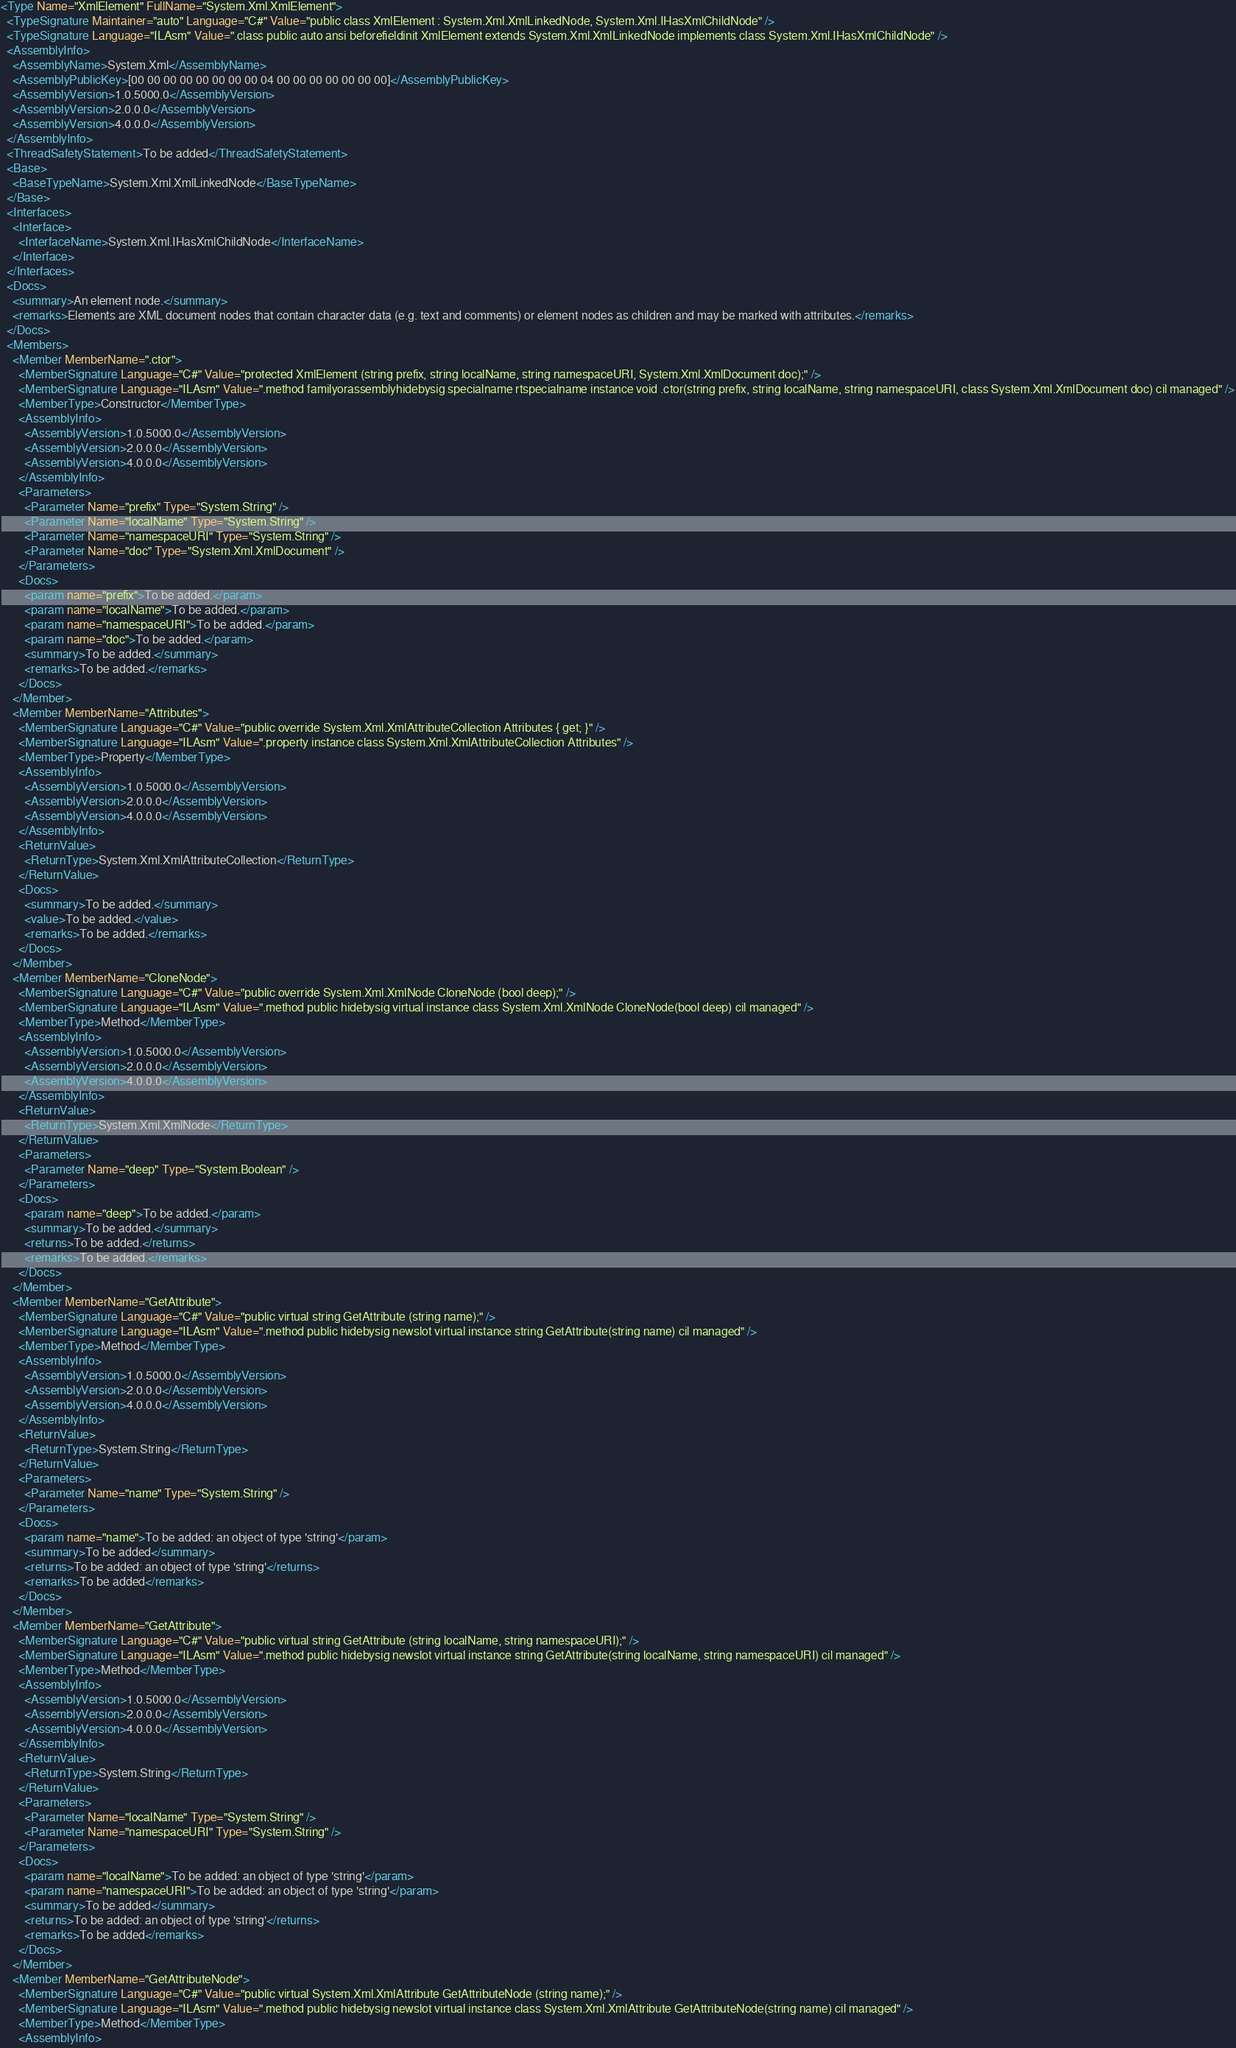<code> <loc_0><loc_0><loc_500><loc_500><_XML_><Type Name="XmlElement" FullName="System.Xml.XmlElement">
  <TypeSignature Maintainer="auto" Language="C#" Value="public class XmlElement : System.Xml.XmlLinkedNode, System.Xml.IHasXmlChildNode" />
  <TypeSignature Language="ILAsm" Value=".class public auto ansi beforefieldinit XmlElement extends System.Xml.XmlLinkedNode implements class System.Xml.IHasXmlChildNode" />
  <AssemblyInfo>
    <AssemblyName>System.Xml</AssemblyName>
    <AssemblyPublicKey>[00 00 00 00 00 00 00 00 04 00 00 00 00 00 00 00]</AssemblyPublicKey>
    <AssemblyVersion>1.0.5000.0</AssemblyVersion>
    <AssemblyVersion>2.0.0.0</AssemblyVersion>
    <AssemblyVersion>4.0.0.0</AssemblyVersion>
  </AssemblyInfo>
  <ThreadSafetyStatement>To be added</ThreadSafetyStatement>
  <Base>
    <BaseTypeName>System.Xml.XmlLinkedNode</BaseTypeName>
  </Base>
  <Interfaces>
    <Interface>
      <InterfaceName>System.Xml.IHasXmlChildNode</InterfaceName>
    </Interface>
  </Interfaces>
  <Docs>
    <summary>An element node.</summary>
    <remarks>Elements are XML document nodes that contain character data (e.g. text and comments) or element nodes as children and may be marked with attributes.</remarks>
  </Docs>
  <Members>
    <Member MemberName=".ctor">
      <MemberSignature Language="C#" Value="protected XmlElement (string prefix, string localName, string namespaceURI, System.Xml.XmlDocument doc);" />
      <MemberSignature Language="ILAsm" Value=".method familyorassemblyhidebysig specialname rtspecialname instance void .ctor(string prefix, string localName, string namespaceURI, class System.Xml.XmlDocument doc) cil managed" />
      <MemberType>Constructor</MemberType>
      <AssemblyInfo>
        <AssemblyVersion>1.0.5000.0</AssemblyVersion>
        <AssemblyVersion>2.0.0.0</AssemblyVersion>
        <AssemblyVersion>4.0.0.0</AssemblyVersion>
      </AssemblyInfo>
      <Parameters>
        <Parameter Name="prefix" Type="System.String" />
        <Parameter Name="localName" Type="System.String" />
        <Parameter Name="namespaceURI" Type="System.String" />
        <Parameter Name="doc" Type="System.Xml.XmlDocument" />
      </Parameters>
      <Docs>
        <param name="prefix">To be added.</param>
        <param name="localName">To be added.</param>
        <param name="namespaceURI">To be added.</param>
        <param name="doc">To be added.</param>
        <summary>To be added.</summary>
        <remarks>To be added.</remarks>
      </Docs>
    </Member>
    <Member MemberName="Attributes">
      <MemberSignature Language="C#" Value="public override System.Xml.XmlAttributeCollection Attributes { get; }" />
      <MemberSignature Language="ILAsm" Value=".property instance class System.Xml.XmlAttributeCollection Attributes" />
      <MemberType>Property</MemberType>
      <AssemblyInfo>
        <AssemblyVersion>1.0.5000.0</AssemblyVersion>
        <AssemblyVersion>2.0.0.0</AssemblyVersion>
        <AssemblyVersion>4.0.0.0</AssemblyVersion>
      </AssemblyInfo>
      <ReturnValue>
        <ReturnType>System.Xml.XmlAttributeCollection</ReturnType>
      </ReturnValue>
      <Docs>
        <summary>To be added.</summary>
        <value>To be added.</value>
        <remarks>To be added.</remarks>
      </Docs>
    </Member>
    <Member MemberName="CloneNode">
      <MemberSignature Language="C#" Value="public override System.Xml.XmlNode CloneNode (bool deep);" />
      <MemberSignature Language="ILAsm" Value=".method public hidebysig virtual instance class System.Xml.XmlNode CloneNode(bool deep) cil managed" />
      <MemberType>Method</MemberType>
      <AssemblyInfo>
        <AssemblyVersion>1.0.5000.0</AssemblyVersion>
        <AssemblyVersion>2.0.0.0</AssemblyVersion>
        <AssemblyVersion>4.0.0.0</AssemblyVersion>
      </AssemblyInfo>
      <ReturnValue>
        <ReturnType>System.Xml.XmlNode</ReturnType>
      </ReturnValue>
      <Parameters>
        <Parameter Name="deep" Type="System.Boolean" />
      </Parameters>
      <Docs>
        <param name="deep">To be added.</param>
        <summary>To be added.</summary>
        <returns>To be added.</returns>
        <remarks>To be added.</remarks>
      </Docs>
    </Member>
    <Member MemberName="GetAttribute">
      <MemberSignature Language="C#" Value="public virtual string GetAttribute (string name);" />
      <MemberSignature Language="ILAsm" Value=".method public hidebysig newslot virtual instance string GetAttribute(string name) cil managed" />
      <MemberType>Method</MemberType>
      <AssemblyInfo>
        <AssemblyVersion>1.0.5000.0</AssemblyVersion>
        <AssemblyVersion>2.0.0.0</AssemblyVersion>
        <AssemblyVersion>4.0.0.0</AssemblyVersion>
      </AssemblyInfo>
      <ReturnValue>
        <ReturnType>System.String</ReturnType>
      </ReturnValue>
      <Parameters>
        <Parameter Name="name" Type="System.String" />
      </Parameters>
      <Docs>
        <param name="name">To be added: an object of type 'string'</param>
        <summary>To be added</summary>
        <returns>To be added: an object of type 'string'</returns>
        <remarks>To be added</remarks>
      </Docs>
    </Member>
    <Member MemberName="GetAttribute">
      <MemberSignature Language="C#" Value="public virtual string GetAttribute (string localName, string namespaceURI);" />
      <MemberSignature Language="ILAsm" Value=".method public hidebysig newslot virtual instance string GetAttribute(string localName, string namespaceURI) cil managed" />
      <MemberType>Method</MemberType>
      <AssemblyInfo>
        <AssemblyVersion>1.0.5000.0</AssemblyVersion>
        <AssemblyVersion>2.0.0.0</AssemblyVersion>
        <AssemblyVersion>4.0.0.0</AssemblyVersion>
      </AssemblyInfo>
      <ReturnValue>
        <ReturnType>System.String</ReturnType>
      </ReturnValue>
      <Parameters>
        <Parameter Name="localName" Type="System.String" />
        <Parameter Name="namespaceURI" Type="System.String" />
      </Parameters>
      <Docs>
        <param name="localName">To be added: an object of type 'string'</param>
        <param name="namespaceURI">To be added: an object of type 'string'</param>
        <summary>To be added</summary>
        <returns>To be added: an object of type 'string'</returns>
        <remarks>To be added</remarks>
      </Docs>
    </Member>
    <Member MemberName="GetAttributeNode">
      <MemberSignature Language="C#" Value="public virtual System.Xml.XmlAttribute GetAttributeNode (string name);" />
      <MemberSignature Language="ILAsm" Value=".method public hidebysig newslot virtual instance class System.Xml.XmlAttribute GetAttributeNode(string name) cil managed" />
      <MemberType>Method</MemberType>
      <AssemblyInfo></code> 